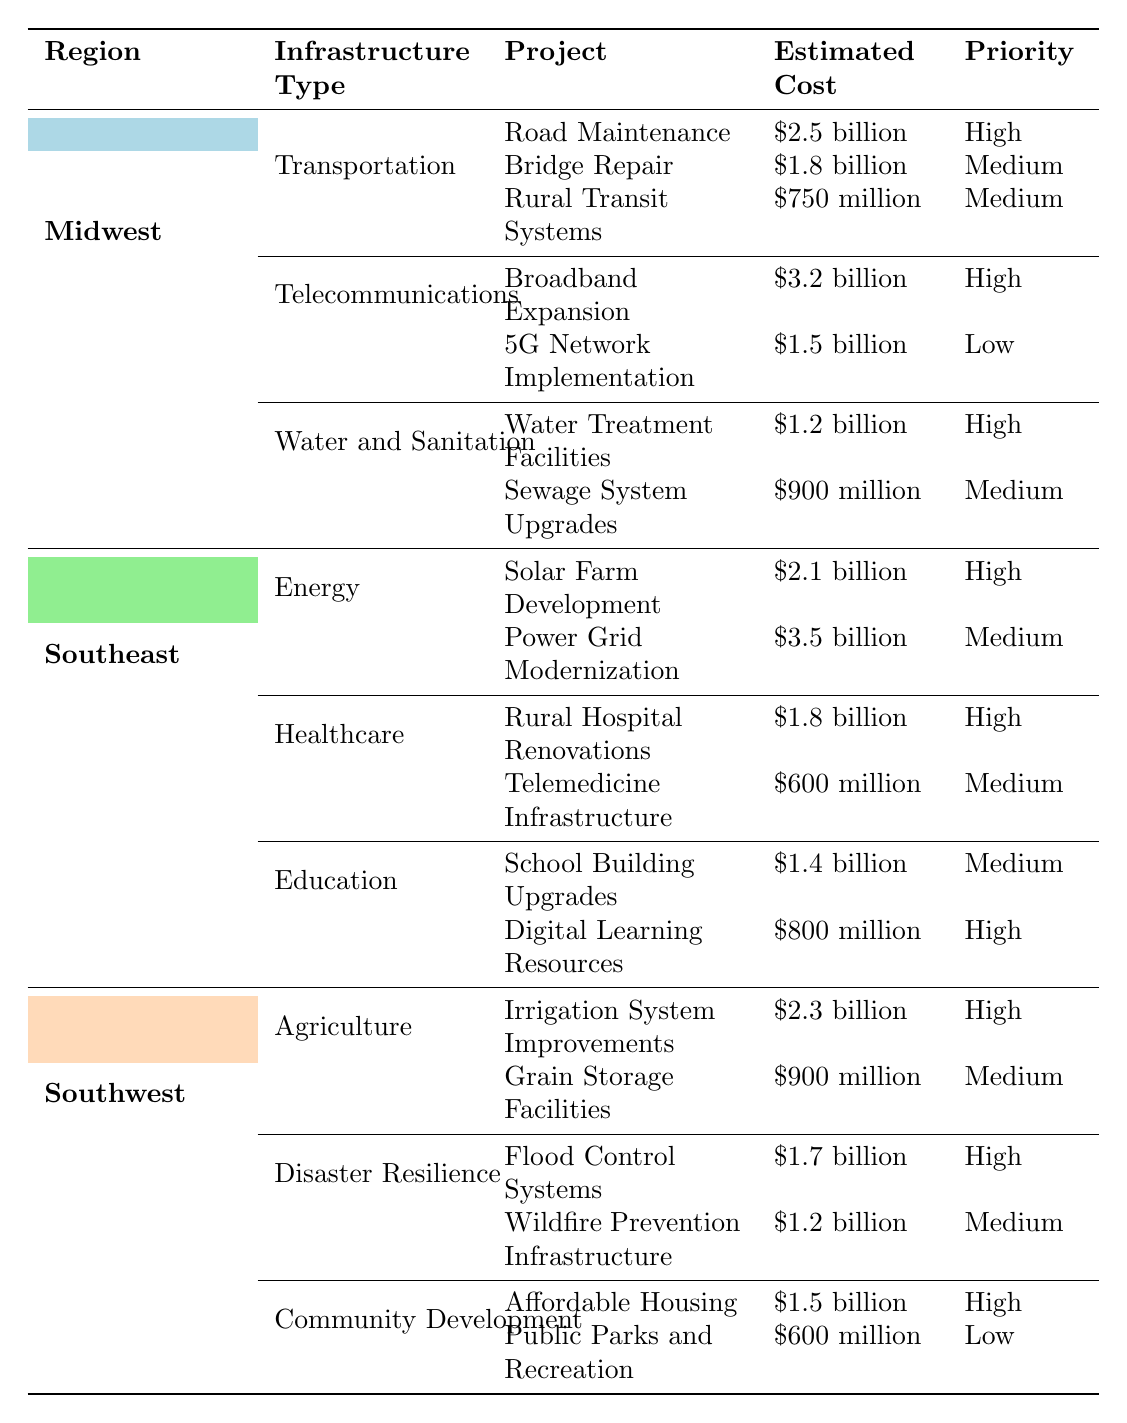What is the total estimated cost for transportation projects in the Midwest? In the Midwest region, the transportation projects' estimated costs are: Road Maintenance ($2.5 billion), Bridge Repair ($1.8 billion), and Rural Transit Systems ($750 million). Summing these amounts: 2.5 + 1.8 + 0.75 = 5.05 billion.
Answer: $5.05 billion Which region has the highest estimated cost for energy infrastructure? In the Southeast region, the estimated cost for energy infrastructure projects is: Solar Farm Development ($2.1 billion) and Power Grid Modernization ($3.5 billion). The highest cost is from Power Grid Modernization, which is $3.5 billion.
Answer: Southeast How many projects in the Southwest region have a high priority? In the Southwest region, the following high-priority projects are listed: Irrigation System Improvements, Flood Control Systems, and Affordable Housing. Thus, there are 3 high-priority projects.
Answer: 3 What is the total estimated cost for healthcare-related projects in the Southeast? The healthcare-related projects in the Southeast region are: Rural Hospital Renovations ($1.8 billion) and Telemedicine Infrastructure ($600 million). Summing these amounts gives 1.8 + 0.6 = 2.4 billion.
Answer: $2.4 billion Is the estimated cost for the bridge repair in the Midwest higher than the estimated cost for the rural hospital renovations in the Southeast? The estimated cost for the bridge repair in the Midwest is $1.8 billion, while the cost for rural hospital renovations in the Southeast is $1.8 billion. Since they are equal, the answer is no.
Answer: No What is the combined estimated cost of all water and sanitation needs in the Midwest? The water and sanitation needs in the Midwest are: Water Treatment Facilities ($1.2 billion) and Sewage System Upgrades ($900 million). Combining these costs gives 1.2 + 0.9 = 2.1 billion.
Answer: $2.1 billion Which two regions have high-priority projects that exceed $2 billion? In the Southeast, the Power Grid Modernization ($3.5 billion) has a high priority, and in the Midwest, Broadband Expansion ($3.2 billion) also exceeds $2 billion. Thus, those two regions are Southeast and Midwest.
Answer: Southeast, Midwest What is the priority level of the public parks and recreation project in the Southwest? The public parks and recreation project in the Southwest has a recorded priority level of low.
Answer: Low How does the total estimated cost for disaster resilience projects in the Southwest compare to the education projects in the Southeast? The total estimated cost for disaster resilience in the Southwest consists of Flood Control Systems ($1.7 billion) and Wildfire Prevention Infrastructure ($1.2 billion), which sums to 1.7 + 1.2 = 2.9 billion. For education in Southeast: School Building Upgrades ($1.4 billion) and Digital Learning Resources ($800 million), which sums to 1.4 + 0.8 = 2.2 billion. Since 2.9 billion exceeds 2.2 billion, the disaster resilience projects are higher.
Answer: Disaster resilience projects are higher 